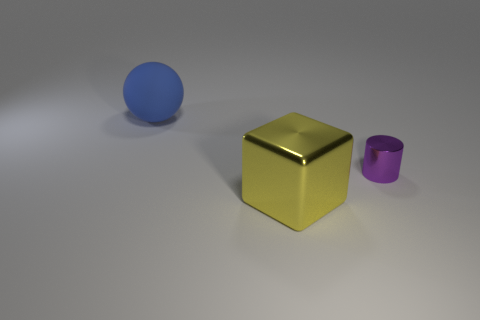Does the lighting have any special effect on how the objects are perceived? Indeed, the lighting plays a crucial role in the perception of the objects. The soft overhead lighting creates gentle shadows that give depth to the scene and accentuate the three-dimensionality of the objects. Notably, the shiny surface of the golden cube reflects the light, highlighting its prominence in the image, while the matte surfaces of the sphere and cylinder absorb the light, giving them a more subdued presence. 